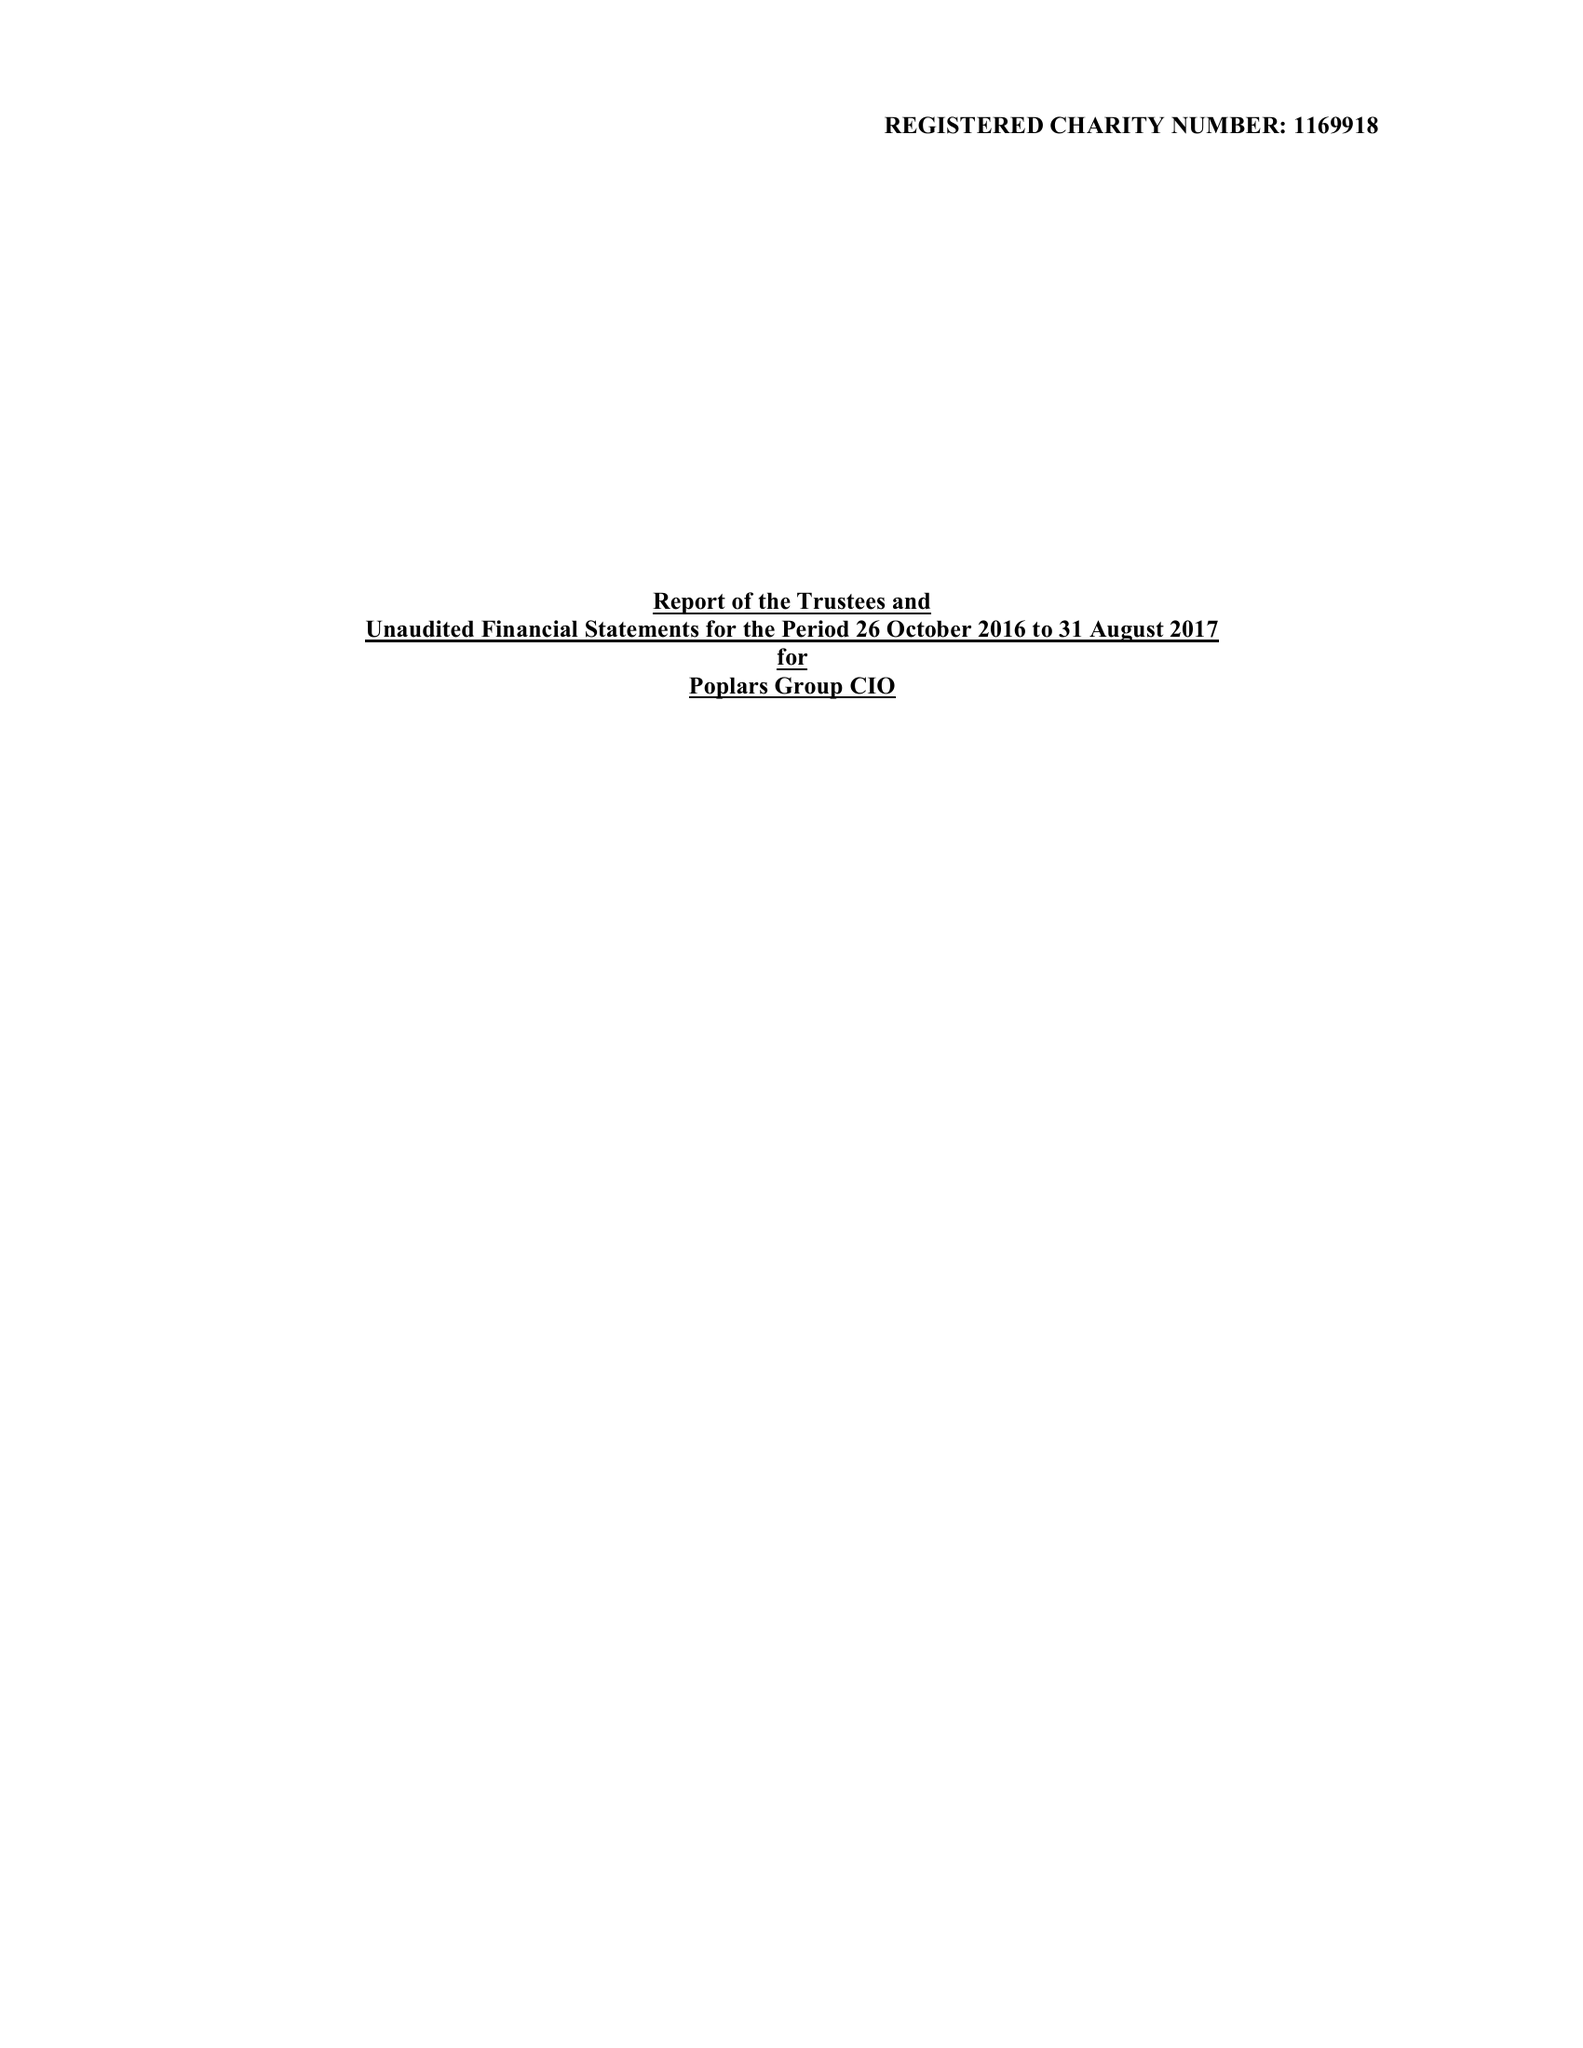What is the value for the address__post_town?
Answer the question using a single word or phrase. WIGSTON 